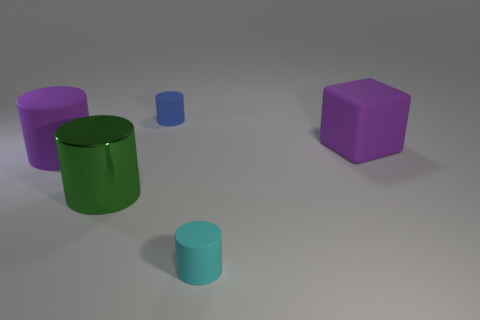What could be the context or setting of this image? The image seems to be a 3D rendering or artistic depiction of various geometric shapes in an empty space. The shadows and light suggest that there is a single light source, likely artificial, from above. The simplicity and cleanliness of the space might suggest a focus on form and color, potentially for educational or illustrative purposes.  What do you think is the size relation between these objects? Based on their relative sizes and the shadows cast, the large green cylinder appears to be the tallest object, followed by the purple cube. The small blue cylinder is the next in size and the smaller green cylinder is the shortest and most petite object visible. 